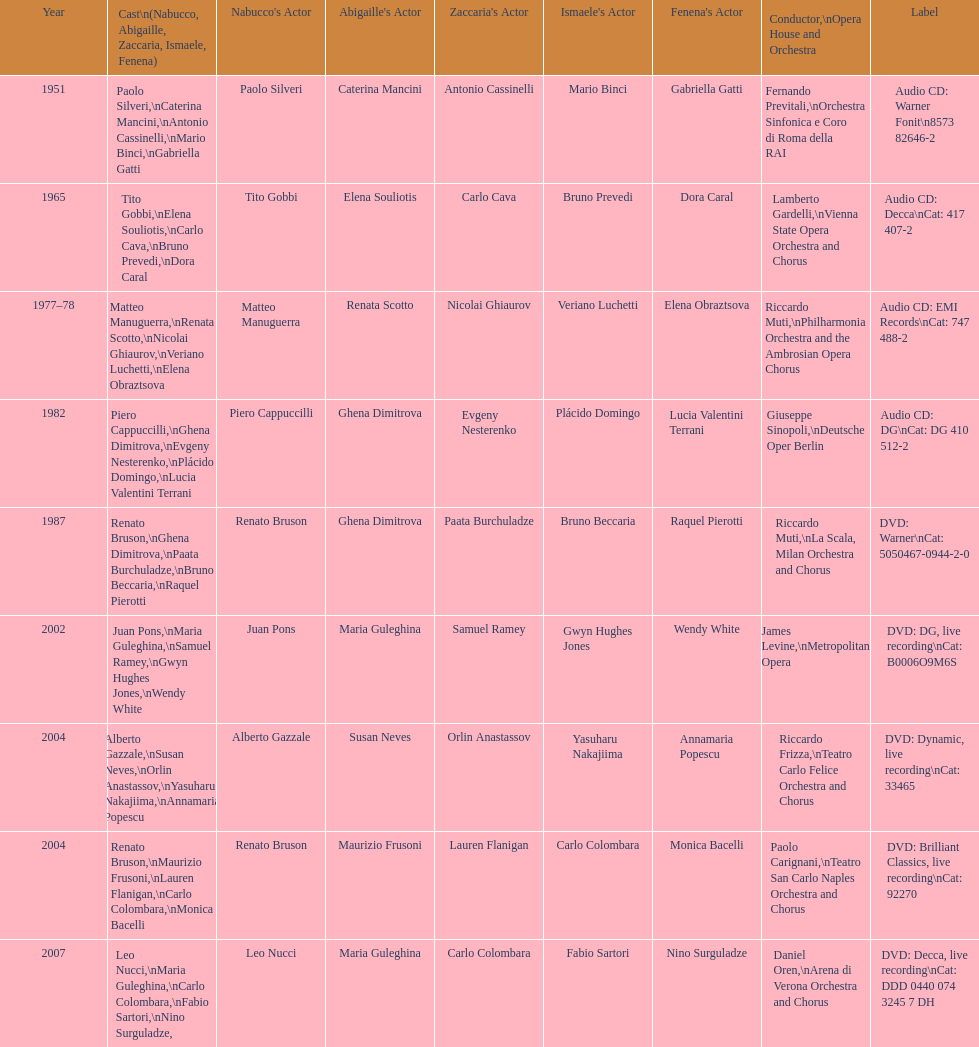When was the recording of nabucco made in the metropolitan opera? 2002. 